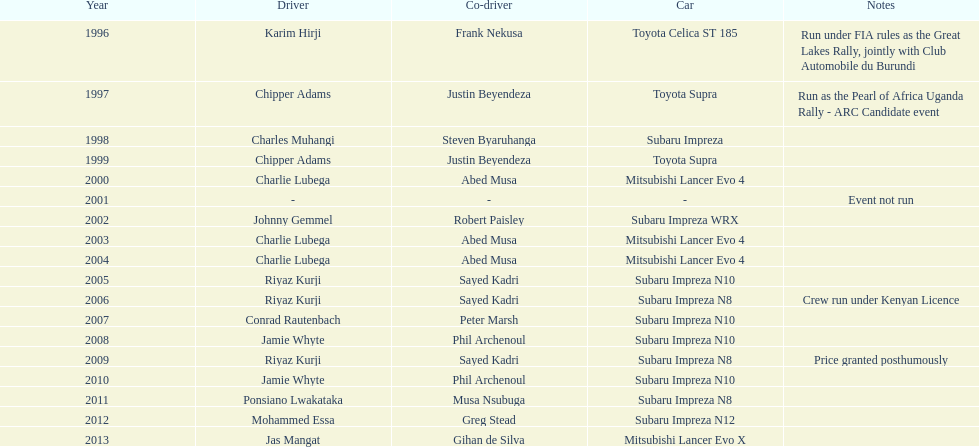Which was the only year that the event was not run? 2001. 